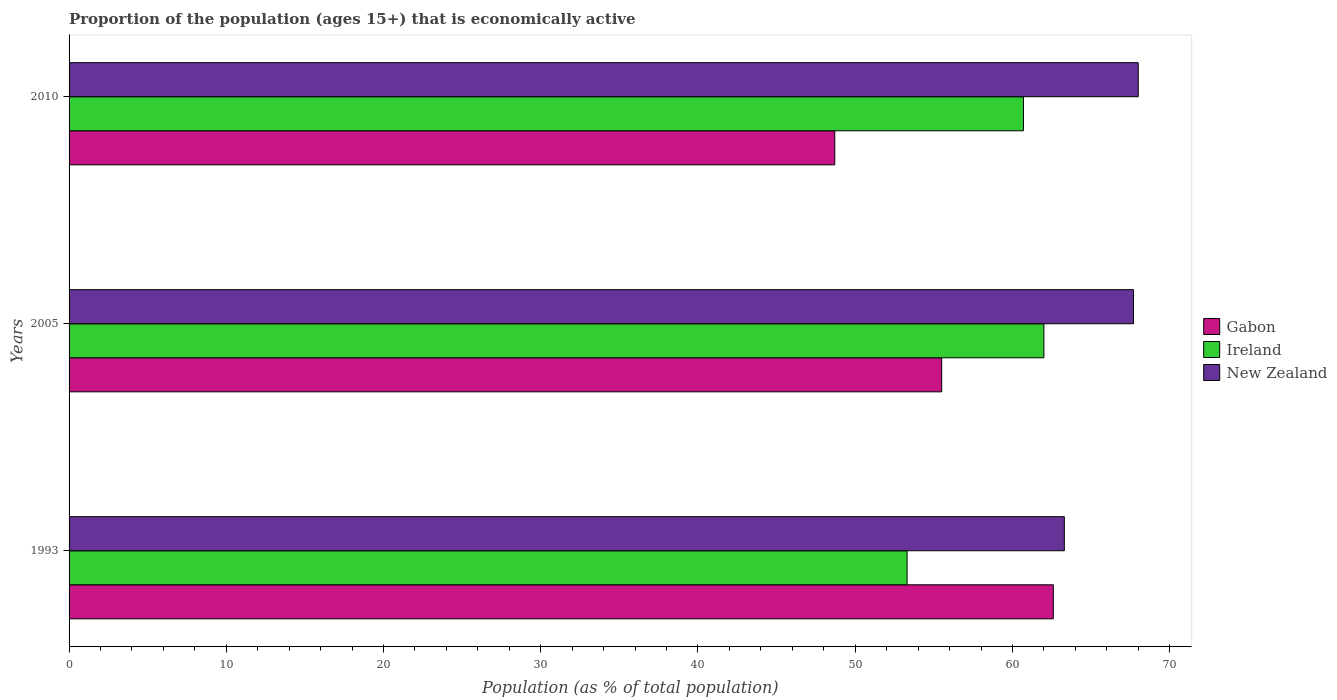How many groups of bars are there?
Your answer should be very brief. 3. How many bars are there on the 1st tick from the top?
Offer a very short reply. 3. What is the label of the 1st group of bars from the top?
Make the answer very short. 2010. In how many cases, is the number of bars for a given year not equal to the number of legend labels?
Your answer should be very brief. 0. What is the proportion of the population that is economically active in Ireland in 1993?
Your answer should be very brief. 53.3. Across all years, what is the maximum proportion of the population that is economically active in Gabon?
Provide a short and direct response. 62.6. Across all years, what is the minimum proportion of the population that is economically active in New Zealand?
Your response must be concise. 63.3. In which year was the proportion of the population that is economically active in Ireland minimum?
Give a very brief answer. 1993. What is the total proportion of the population that is economically active in New Zealand in the graph?
Give a very brief answer. 199. What is the difference between the proportion of the population that is economically active in New Zealand in 1993 and that in 2010?
Provide a succinct answer. -4.7. What is the difference between the proportion of the population that is economically active in Ireland in 2005 and the proportion of the population that is economically active in Gabon in 1993?
Offer a terse response. -0.6. What is the average proportion of the population that is economically active in Ireland per year?
Your response must be concise. 58.67. In the year 2010, what is the difference between the proportion of the population that is economically active in New Zealand and proportion of the population that is economically active in Ireland?
Your answer should be compact. 7.3. In how many years, is the proportion of the population that is economically active in Gabon greater than 46 %?
Provide a succinct answer. 3. What is the ratio of the proportion of the population that is economically active in Gabon in 1993 to that in 2005?
Offer a very short reply. 1.13. Is the difference between the proportion of the population that is economically active in New Zealand in 1993 and 2005 greater than the difference between the proportion of the population that is economically active in Ireland in 1993 and 2005?
Offer a very short reply. Yes. What is the difference between the highest and the second highest proportion of the population that is economically active in Ireland?
Keep it short and to the point. 1.3. What is the difference between the highest and the lowest proportion of the population that is economically active in Ireland?
Your answer should be very brief. 8.7. Is the sum of the proportion of the population that is economically active in Ireland in 1993 and 2005 greater than the maximum proportion of the population that is economically active in New Zealand across all years?
Your answer should be very brief. Yes. What does the 1st bar from the top in 2005 represents?
Your answer should be very brief. New Zealand. What does the 2nd bar from the bottom in 1993 represents?
Keep it short and to the point. Ireland. Is it the case that in every year, the sum of the proportion of the population that is economically active in New Zealand and proportion of the population that is economically active in Gabon is greater than the proportion of the population that is economically active in Ireland?
Provide a short and direct response. Yes. How many bars are there?
Keep it short and to the point. 9. What is the difference between two consecutive major ticks on the X-axis?
Make the answer very short. 10. Are the values on the major ticks of X-axis written in scientific E-notation?
Provide a short and direct response. No. Does the graph contain any zero values?
Your answer should be compact. No. Where does the legend appear in the graph?
Offer a terse response. Center right. What is the title of the graph?
Provide a succinct answer. Proportion of the population (ages 15+) that is economically active. What is the label or title of the X-axis?
Give a very brief answer. Population (as % of total population). What is the Population (as % of total population) in Gabon in 1993?
Your answer should be compact. 62.6. What is the Population (as % of total population) in Ireland in 1993?
Offer a very short reply. 53.3. What is the Population (as % of total population) of New Zealand in 1993?
Make the answer very short. 63.3. What is the Population (as % of total population) in Gabon in 2005?
Offer a terse response. 55.5. What is the Population (as % of total population) of Ireland in 2005?
Keep it short and to the point. 62. What is the Population (as % of total population) of New Zealand in 2005?
Keep it short and to the point. 67.7. What is the Population (as % of total population) of Gabon in 2010?
Ensure brevity in your answer.  48.7. What is the Population (as % of total population) in Ireland in 2010?
Ensure brevity in your answer.  60.7. Across all years, what is the maximum Population (as % of total population) of Gabon?
Your answer should be compact. 62.6. Across all years, what is the maximum Population (as % of total population) in New Zealand?
Your answer should be very brief. 68. Across all years, what is the minimum Population (as % of total population) of Gabon?
Your response must be concise. 48.7. Across all years, what is the minimum Population (as % of total population) of Ireland?
Your response must be concise. 53.3. Across all years, what is the minimum Population (as % of total population) of New Zealand?
Keep it short and to the point. 63.3. What is the total Population (as % of total population) in Gabon in the graph?
Your answer should be very brief. 166.8. What is the total Population (as % of total population) of Ireland in the graph?
Your answer should be very brief. 176. What is the total Population (as % of total population) of New Zealand in the graph?
Offer a terse response. 199. What is the difference between the Population (as % of total population) in Gabon in 1993 and that in 2005?
Ensure brevity in your answer.  7.1. What is the difference between the Population (as % of total population) of Gabon in 1993 and that in 2010?
Offer a very short reply. 13.9. What is the difference between the Population (as % of total population) of New Zealand in 1993 and that in 2010?
Offer a very short reply. -4.7. What is the difference between the Population (as % of total population) of Ireland in 2005 and that in 2010?
Provide a short and direct response. 1.3. What is the difference between the Population (as % of total population) in Gabon in 1993 and the Population (as % of total population) in Ireland in 2005?
Provide a succinct answer. 0.6. What is the difference between the Population (as % of total population) of Ireland in 1993 and the Population (as % of total population) of New Zealand in 2005?
Provide a succinct answer. -14.4. What is the difference between the Population (as % of total population) of Gabon in 1993 and the Population (as % of total population) of Ireland in 2010?
Ensure brevity in your answer.  1.9. What is the difference between the Population (as % of total population) in Gabon in 1993 and the Population (as % of total population) in New Zealand in 2010?
Your response must be concise. -5.4. What is the difference between the Population (as % of total population) of Ireland in 1993 and the Population (as % of total population) of New Zealand in 2010?
Offer a terse response. -14.7. What is the average Population (as % of total population) of Gabon per year?
Your answer should be very brief. 55.6. What is the average Population (as % of total population) in Ireland per year?
Your response must be concise. 58.67. What is the average Population (as % of total population) in New Zealand per year?
Offer a very short reply. 66.33. In the year 1993, what is the difference between the Population (as % of total population) in Gabon and Population (as % of total population) in Ireland?
Your answer should be very brief. 9.3. In the year 1993, what is the difference between the Population (as % of total population) in Gabon and Population (as % of total population) in New Zealand?
Give a very brief answer. -0.7. In the year 1993, what is the difference between the Population (as % of total population) of Ireland and Population (as % of total population) of New Zealand?
Your answer should be very brief. -10. In the year 2005, what is the difference between the Population (as % of total population) in Gabon and Population (as % of total population) in Ireland?
Provide a succinct answer. -6.5. In the year 2005, what is the difference between the Population (as % of total population) in Ireland and Population (as % of total population) in New Zealand?
Offer a terse response. -5.7. In the year 2010, what is the difference between the Population (as % of total population) of Gabon and Population (as % of total population) of New Zealand?
Ensure brevity in your answer.  -19.3. What is the ratio of the Population (as % of total population) in Gabon in 1993 to that in 2005?
Ensure brevity in your answer.  1.13. What is the ratio of the Population (as % of total population) of Ireland in 1993 to that in 2005?
Provide a succinct answer. 0.86. What is the ratio of the Population (as % of total population) of New Zealand in 1993 to that in 2005?
Your response must be concise. 0.94. What is the ratio of the Population (as % of total population) of Gabon in 1993 to that in 2010?
Offer a very short reply. 1.29. What is the ratio of the Population (as % of total population) in Ireland in 1993 to that in 2010?
Offer a very short reply. 0.88. What is the ratio of the Population (as % of total population) of New Zealand in 1993 to that in 2010?
Your answer should be very brief. 0.93. What is the ratio of the Population (as % of total population) of Gabon in 2005 to that in 2010?
Your answer should be very brief. 1.14. What is the ratio of the Population (as % of total population) in Ireland in 2005 to that in 2010?
Make the answer very short. 1.02. What is the ratio of the Population (as % of total population) of New Zealand in 2005 to that in 2010?
Offer a terse response. 1. What is the difference between the highest and the second highest Population (as % of total population) of Gabon?
Provide a succinct answer. 7.1. What is the difference between the highest and the lowest Population (as % of total population) in Gabon?
Offer a very short reply. 13.9. 